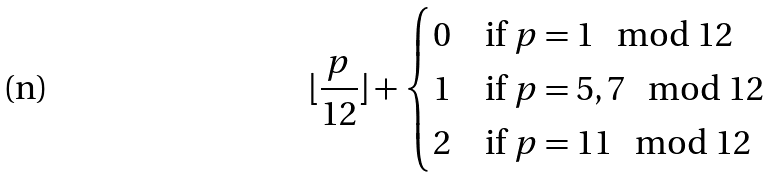Convert formula to latex. <formula><loc_0><loc_0><loc_500><loc_500>\lfloor \frac { p } { 1 2 } \rfloor + \begin{cases} 0 & \text {if $p=1\mod 12$} \\ 1 & \text {if $p=5,7\mod 12$} \\ 2 & \text {if $p=11\mod 12$} \end{cases}</formula> 